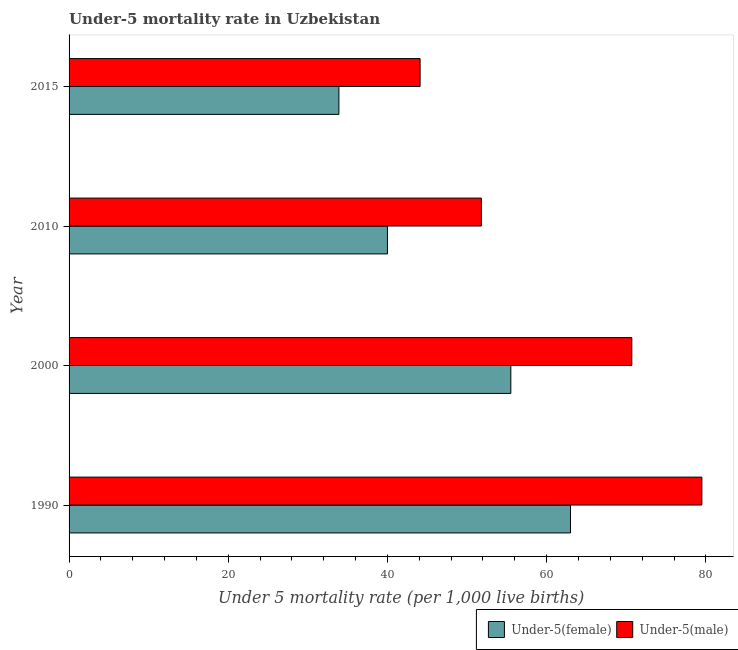How many bars are there on the 4th tick from the top?
Your answer should be compact. 2. What is the label of the 1st group of bars from the top?
Your answer should be compact. 2015. In how many cases, is the number of bars for a given year not equal to the number of legend labels?
Your answer should be very brief. 0. What is the under-5 male mortality rate in 1990?
Give a very brief answer. 79.5. Across all years, what is the maximum under-5 male mortality rate?
Provide a succinct answer. 79.5. Across all years, what is the minimum under-5 male mortality rate?
Your answer should be compact. 44.1. In which year was the under-5 male mortality rate maximum?
Provide a short and direct response. 1990. In which year was the under-5 female mortality rate minimum?
Ensure brevity in your answer.  2015. What is the total under-5 male mortality rate in the graph?
Ensure brevity in your answer.  246.1. What is the difference between the under-5 male mortality rate in 2000 and that in 2015?
Your answer should be very brief. 26.6. What is the difference between the under-5 female mortality rate in 2010 and the under-5 male mortality rate in 2000?
Offer a terse response. -30.7. What is the average under-5 male mortality rate per year?
Your answer should be compact. 61.52. In how many years, is the under-5 female mortality rate greater than 56 ?
Give a very brief answer. 1. What is the ratio of the under-5 female mortality rate in 2010 to that in 2015?
Offer a terse response. 1.18. What is the difference between the highest and the second highest under-5 male mortality rate?
Make the answer very short. 8.8. What is the difference between the highest and the lowest under-5 male mortality rate?
Your response must be concise. 35.4. In how many years, is the under-5 female mortality rate greater than the average under-5 female mortality rate taken over all years?
Your response must be concise. 2. Is the sum of the under-5 male mortality rate in 1990 and 2000 greater than the maximum under-5 female mortality rate across all years?
Ensure brevity in your answer.  Yes. What does the 2nd bar from the top in 1990 represents?
Keep it short and to the point. Under-5(female). What does the 1st bar from the bottom in 2015 represents?
Give a very brief answer. Under-5(female). How many years are there in the graph?
Provide a succinct answer. 4. What is the difference between two consecutive major ticks on the X-axis?
Your answer should be compact. 20. Where does the legend appear in the graph?
Provide a succinct answer. Bottom right. How are the legend labels stacked?
Keep it short and to the point. Horizontal. What is the title of the graph?
Your answer should be very brief. Under-5 mortality rate in Uzbekistan. What is the label or title of the X-axis?
Your answer should be very brief. Under 5 mortality rate (per 1,0 live births). What is the label or title of the Y-axis?
Your answer should be compact. Year. What is the Under 5 mortality rate (per 1,000 live births) in Under-5(male) in 1990?
Make the answer very short. 79.5. What is the Under 5 mortality rate (per 1,000 live births) of Under-5(female) in 2000?
Make the answer very short. 55.5. What is the Under 5 mortality rate (per 1,000 live births) in Under-5(male) in 2000?
Provide a succinct answer. 70.7. What is the Under 5 mortality rate (per 1,000 live births) of Under-5(male) in 2010?
Your answer should be very brief. 51.8. What is the Under 5 mortality rate (per 1,000 live births) in Under-5(female) in 2015?
Your response must be concise. 33.9. What is the Under 5 mortality rate (per 1,000 live births) of Under-5(male) in 2015?
Your answer should be very brief. 44.1. Across all years, what is the maximum Under 5 mortality rate (per 1,000 live births) in Under-5(male)?
Give a very brief answer. 79.5. Across all years, what is the minimum Under 5 mortality rate (per 1,000 live births) of Under-5(female)?
Make the answer very short. 33.9. Across all years, what is the minimum Under 5 mortality rate (per 1,000 live births) of Under-5(male)?
Give a very brief answer. 44.1. What is the total Under 5 mortality rate (per 1,000 live births) of Under-5(female) in the graph?
Your answer should be very brief. 192.4. What is the total Under 5 mortality rate (per 1,000 live births) of Under-5(male) in the graph?
Give a very brief answer. 246.1. What is the difference between the Under 5 mortality rate (per 1,000 live births) of Under-5(female) in 1990 and that in 2000?
Your answer should be very brief. 7.5. What is the difference between the Under 5 mortality rate (per 1,000 live births) of Under-5(male) in 1990 and that in 2010?
Ensure brevity in your answer.  27.7. What is the difference between the Under 5 mortality rate (per 1,000 live births) of Under-5(female) in 1990 and that in 2015?
Keep it short and to the point. 29.1. What is the difference between the Under 5 mortality rate (per 1,000 live births) of Under-5(male) in 1990 and that in 2015?
Provide a short and direct response. 35.4. What is the difference between the Under 5 mortality rate (per 1,000 live births) in Under-5(female) in 2000 and that in 2010?
Give a very brief answer. 15.5. What is the difference between the Under 5 mortality rate (per 1,000 live births) in Under-5(male) in 2000 and that in 2010?
Your response must be concise. 18.9. What is the difference between the Under 5 mortality rate (per 1,000 live births) in Under-5(female) in 2000 and that in 2015?
Give a very brief answer. 21.6. What is the difference between the Under 5 mortality rate (per 1,000 live births) in Under-5(male) in 2000 and that in 2015?
Your answer should be very brief. 26.6. What is the difference between the Under 5 mortality rate (per 1,000 live births) in Under-5(male) in 2010 and that in 2015?
Ensure brevity in your answer.  7.7. What is the difference between the Under 5 mortality rate (per 1,000 live births) of Under-5(female) in 1990 and the Under 5 mortality rate (per 1,000 live births) of Under-5(male) in 2000?
Keep it short and to the point. -7.7. What is the difference between the Under 5 mortality rate (per 1,000 live births) in Under-5(female) in 1990 and the Under 5 mortality rate (per 1,000 live births) in Under-5(male) in 2010?
Your answer should be very brief. 11.2. What is the difference between the Under 5 mortality rate (per 1,000 live births) in Under-5(female) in 1990 and the Under 5 mortality rate (per 1,000 live births) in Under-5(male) in 2015?
Give a very brief answer. 18.9. What is the difference between the Under 5 mortality rate (per 1,000 live births) of Under-5(female) in 2000 and the Under 5 mortality rate (per 1,000 live births) of Under-5(male) in 2010?
Offer a terse response. 3.7. What is the average Under 5 mortality rate (per 1,000 live births) in Under-5(female) per year?
Offer a terse response. 48.1. What is the average Under 5 mortality rate (per 1,000 live births) of Under-5(male) per year?
Your answer should be very brief. 61.52. In the year 1990, what is the difference between the Under 5 mortality rate (per 1,000 live births) of Under-5(female) and Under 5 mortality rate (per 1,000 live births) of Under-5(male)?
Ensure brevity in your answer.  -16.5. In the year 2000, what is the difference between the Under 5 mortality rate (per 1,000 live births) of Under-5(female) and Under 5 mortality rate (per 1,000 live births) of Under-5(male)?
Offer a very short reply. -15.2. What is the ratio of the Under 5 mortality rate (per 1,000 live births) in Under-5(female) in 1990 to that in 2000?
Your answer should be very brief. 1.14. What is the ratio of the Under 5 mortality rate (per 1,000 live births) of Under-5(male) in 1990 to that in 2000?
Provide a short and direct response. 1.12. What is the ratio of the Under 5 mortality rate (per 1,000 live births) of Under-5(female) in 1990 to that in 2010?
Offer a terse response. 1.57. What is the ratio of the Under 5 mortality rate (per 1,000 live births) of Under-5(male) in 1990 to that in 2010?
Ensure brevity in your answer.  1.53. What is the ratio of the Under 5 mortality rate (per 1,000 live births) of Under-5(female) in 1990 to that in 2015?
Your answer should be compact. 1.86. What is the ratio of the Under 5 mortality rate (per 1,000 live births) in Under-5(male) in 1990 to that in 2015?
Provide a short and direct response. 1.8. What is the ratio of the Under 5 mortality rate (per 1,000 live births) in Under-5(female) in 2000 to that in 2010?
Make the answer very short. 1.39. What is the ratio of the Under 5 mortality rate (per 1,000 live births) in Under-5(male) in 2000 to that in 2010?
Your answer should be very brief. 1.36. What is the ratio of the Under 5 mortality rate (per 1,000 live births) of Under-5(female) in 2000 to that in 2015?
Keep it short and to the point. 1.64. What is the ratio of the Under 5 mortality rate (per 1,000 live births) of Under-5(male) in 2000 to that in 2015?
Give a very brief answer. 1.6. What is the ratio of the Under 5 mortality rate (per 1,000 live births) of Under-5(female) in 2010 to that in 2015?
Make the answer very short. 1.18. What is the ratio of the Under 5 mortality rate (per 1,000 live births) of Under-5(male) in 2010 to that in 2015?
Make the answer very short. 1.17. What is the difference between the highest and the lowest Under 5 mortality rate (per 1,000 live births) of Under-5(female)?
Your answer should be very brief. 29.1. What is the difference between the highest and the lowest Under 5 mortality rate (per 1,000 live births) in Under-5(male)?
Your answer should be very brief. 35.4. 